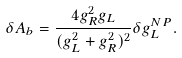Convert formula to latex. <formula><loc_0><loc_0><loc_500><loc_500>\delta A _ { b } = \frac { 4 g _ { R } ^ { 2 } g _ { L } } { ( g _ { L } ^ { 2 } + g _ { R } ^ { 2 } ) ^ { 2 } } \delta g _ { L } ^ { N P } .</formula> 